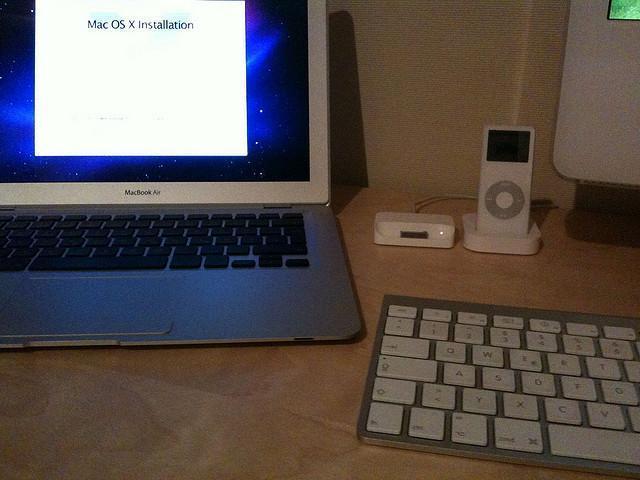How many keyboards are in the photo?
Give a very brief answer. 2. How many people are on the boat that is the main focus?
Give a very brief answer. 0. 